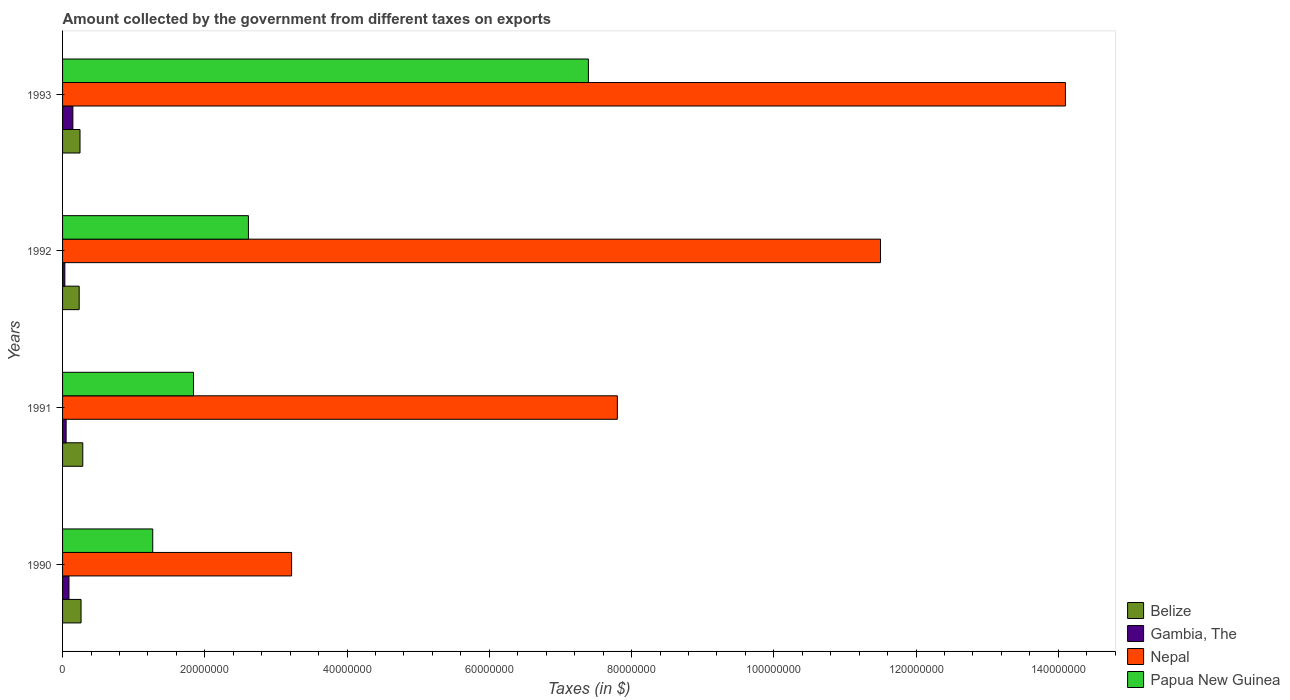What is the label of the 4th group of bars from the top?
Keep it short and to the point. 1990. What is the amount collected by the government from taxes on exports in Papua New Guinea in 1991?
Provide a succinct answer. 1.84e+07. Across all years, what is the maximum amount collected by the government from taxes on exports in Belize?
Your answer should be compact. 2.84e+06. Across all years, what is the minimum amount collected by the government from taxes on exports in Nepal?
Ensure brevity in your answer.  3.22e+07. In which year was the amount collected by the government from taxes on exports in Gambia, The maximum?
Your answer should be compact. 1993. In which year was the amount collected by the government from taxes on exports in Gambia, The minimum?
Your answer should be very brief. 1992. What is the total amount collected by the government from taxes on exports in Nepal in the graph?
Offer a very short reply. 3.66e+08. What is the difference between the amount collected by the government from taxes on exports in Belize in 1990 and that in 1991?
Your response must be concise. -2.42e+05. What is the difference between the amount collected by the government from taxes on exports in Papua New Guinea in 1992 and the amount collected by the government from taxes on exports in Nepal in 1991?
Offer a very short reply. -5.19e+07. What is the average amount collected by the government from taxes on exports in Nepal per year?
Your answer should be very brief. 9.16e+07. In the year 1993, what is the difference between the amount collected by the government from taxes on exports in Belize and amount collected by the government from taxes on exports in Gambia, The?
Provide a short and direct response. 1.00e+06. What is the ratio of the amount collected by the government from taxes on exports in Nepal in 1991 to that in 1992?
Offer a terse response. 0.68. What is the difference between the highest and the second highest amount collected by the government from taxes on exports in Belize?
Provide a short and direct response. 2.42e+05. What is the difference between the highest and the lowest amount collected by the government from taxes on exports in Papua New Guinea?
Offer a very short reply. 6.12e+07. What does the 2nd bar from the top in 1993 represents?
Give a very brief answer. Nepal. What does the 4th bar from the bottom in 1990 represents?
Keep it short and to the point. Papua New Guinea. How many bars are there?
Your answer should be compact. 16. How many years are there in the graph?
Offer a terse response. 4. Does the graph contain any zero values?
Keep it short and to the point. No. Where does the legend appear in the graph?
Give a very brief answer. Bottom right. How are the legend labels stacked?
Give a very brief answer. Vertical. What is the title of the graph?
Your answer should be very brief. Amount collected by the government from different taxes on exports. What is the label or title of the X-axis?
Provide a succinct answer. Taxes (in $). What is the Taxes (in $) in Belize in 1990?
Ensure brevity in your answer.  2.60e+06. What is the Taxes (in $) in Gambia, The in 1990?
Your answer should be compact. 9.00e+05. What is the Taxes (in $) in Nepal in 1990?
Provide a short and direct response. 3.22e+07. What is the Taxes (in $) of Papua New Guinea in 1990?
Your answer should be compact. 1.27e+07. What is the Taxes (in $) of Belize in 1991?
Your answer should be very brief. 2.84e+06. What is the Taxes (in $) of Nepal in 1991?
Your answer should be very brief. 7.80e+07. What is the Taxes (in $) of Papua New Guinea in 1991?
Provide a succinct answer. 1.84e+07. What is the Taxes (in $) of Belize in 1992?
Provide a succinct answer. 2.34e+06. What is the Taxes (in $) of Gambia, The in 1992?
Keep it short and to the point. 3.20e+05. What is the Taxes (in $) of Nepal in 1992?
Your answer should be very brief. 1.15e+08. What is the Taxes (in $) of Papua New Guinea in 1992?
Your answer should be very brief. 2.61e+07. What is the Taxes (in $) of Belize in 1993?
Ensure brevity in your answer.  2.45e+06. What is the Taxes (in $) of Gambia, The in 1993?
Ensure brevity in your answer.  1.45e+06. What is the Taxes (in $) of Nepal in 1993?
Provide a succinct answer. 1.41e+08. What is the Taxes (in $) in Papua New Guinea in 1993?
Offer a terse response. 7.39e+07. Across all years, what is the maximum Taxes (in $) in Belize?
Ensure brevity in your answer.  2.84e+06. Across all years, what is the maximum Taxes (in $) in Gambia, The?
Provide a short and direct response. 1.45e+06. Across all years, what is the maximum Taxes (in $) of Nepal?
Offer a terse response. 1.41e+08. Across all years, what is the maximum Taxes (in $) in Papua New Guinea?
Your answer should be very brief. 7.39e+07. Across all years, what is the minimum Taxes (in $) in Belize?
Offer a very short reply. 2.34e+06. Across all years, what is the minimum Taxes (in $) of Gambia, The?
Keep it short and to the point. 3.20e+05. Across all years, what is the minimum Taxes (in $) in Nepal?
Keep it short and to the point. 3.22e+07. Across all years, what is the minimum Taxes (in $) in Papua New Guinea?
Give a very brief answer. 1.27e+07. What is the total Taxes (in $) in Belize in the graph?
Ensure brevity in your answer.  1.02e+07. What is the total Taxes (in $) in Gambia, The in the graph?
Provide a short and direct response. 3.17e+06. What is the total Taxes (in $) of Nepal in the graph?
Keep it short and to the point. 3.66e+08. What is the total Taxes (in $) of Papua New Guinea in the graph?
Ensure brevity in your answer.  1.31e+08. What is the difference between the Taxes (in $) in Belize in 1990 and that in 1991?
Give a very brief answer. -2.42e+05. What is the difference between the Taxes (in $) of Gambia, The in 1990 and that in 1991?
Your answer should be very brief. 4.00e+05. What is the difference between the Taxes (in $) in Nepal in 1990 and that in 1991?
Ensure brevity in your answer.  -4.58e+07. What is the difference between the Taxes (in $) of Papua New Guinea in 1990 and that in 1991?
Ensure brevity in your answer.  -5.73e+06. What is the difference between the Taxes (in $) in Belize in 1990 and that in 1992?
Provide a short and direct response. 2.65e+05. What is the difference between the Taxes (in $) in Gambia, The in 1990 and that in 1992?
Ensure brevity in your answer.  5.80e+05. What is the difference between the Taxes (in $) in Nepal in 1990 and that in 1992?
Provide a short and direct response. -8.28e+07. What is the difference between the Taxes (in $) in Papua New Guinea in 1990 and that in 1992?
Offer a terse response. -1.34e+07. What is the difference between the Taxes (in $) of Belize in 1990 and that in 1993?
Provide a succinct answer. 1.48e+05. What is the difference between the Taxes (in $) in Gambia, The in 1990 and that in 1993?
Offer a terse response. -5.50e+05. What is the difference between the Taxes (in $) in Nepal in 1990 and that in 1993?
Make the answer very short. -1.09e+08. What is the difference between the Taxes (in $) in Papua New Guinea in 1990 and that in 1993?
Make the answer very short. -6.12e+07. What is the difference between the Taxes (in $) of Belize in 1991 and that in 1992?
Your answer should be compact. 5.07e+05. What is the difference between the Taxes (in $) in Nepal in 1991 and that in 1992?
Your response must be concise. -3.70e+07. What is the difference between the Taxes (in $) of Papua New Guinea in 1991 and that in 1992?
Offer a very short reply. -7.72e+06. What is the difference between the Taxes (in $) of Gambia, The in 1991 and that in 1993?
Offer a terse response. -9.50e+05. What is the difference between the Taxes (in $) of Nepal in 1991 and that in 1993?
Keep it short and to the point. -6.30e+07. What is the difference between the Taxes (in $) in Papua New Guinea in 1991 and that in 1993?
Provide a short and direct response. -5.55e+07. What is the difference between the Taxes (in $) of Belize in 1992 and that in 1993?
Ensure brevity in your answer.  -1.17e+05. What is the difference between the Taxes (in $) in Gambia, The in 1992 and that in 1993?
Your answer should be very brief. -1.13e+06. What is the difference between the Taxes (in $) of Nepal in 1992 and that in 1993?
Keep it short and to the point. -2.60e+07. What is the difference between the Taxes (in $) of Papua New Guinea in 1992 and that in 1993?
Offer a terse response. -4.78e+07. What is the difference between the Taxes (in $) in Belize in 1990 and the Taxes (in $) in Gambia, The in 1991?
Provide a short and direct response. 2.10e+06. What is the difference between the Taxes (in $) of Belize in 1990 and the Taxes (in $) of Nepal in 1991?
Keep it short and to the point. -7.54e+07. What is the difference between the Taxes (in $) in Belize in 1990 and the Taxes (in $) in Papua New Guinea in 1991?
Provide a succinct answer. -1.58e+07. What is the difference between the Taxes (in $) in Gambia, The in 1990 and the Taxes (in $) in Nepal in 1991?
Keep it short and to the point. -7.71e+07. What is the difference between the Taxes (in $) of Gambia, The in 1990 and the Taxes (in $) of Papua New Guinea in 1991?
Provide a short and direct response. -1.75e+07. What is the difference between the Taxes (in $) of Nepal in 1990 and the Taxes (in $) of Papua New Guinea in 1991?
Ensure brevity in your answer.  1.38e+07. What is the difference between the Taxes (in $) of Belize in 1990 and the Taxes (in $) of Gambia, The in 1992?
Provide a succinct answer. 2.28e+06. What is the difference between the Taxes (in $) of Belize in 1990 and the Taxes (in $) of Nepal in 1992?
Ensure brevity in your answer.  -1.12e+08. What is the difference between the Taxes (in $) in Belize in 1990 and the Taxes (in $) in Papua New Guinea in 1992?
Offer a terse response. -2.35e+07. What is the difference between the Taxes (in $) in Gambia, The in 1990 and the Taxes (in $) in Nepal in 1992?
Keep it short and to the point. -1.14e+08. What is the difference between the Taxes (in $) in Gambia, The in 1990 and the Taxes (in $) in Papua New Guinea in 1992?
Offer a terse response. -2.52e+07. What is the difference between the Taxes (in $) of Nepal in 1990 and the Taxes (in $) of Papua New Guinea in 1992?
Give a very brief answer. 6.07e+06. What is the difference between the Taxes (in $) of Belize in 1990 and the Taxes (in $) of Gambia, The in 1993?
Your answer should be compact. 1.15e+06. What is the difference between the Taxes (in $) in Belize in 1990 and the Taxes (in $) in Nepal in 1993?
Keep it short and to the point. -1.38e+08. What is the difference between the Taxes (in $) of Belize in 1990 and the Taxes (in $) of Papua New Guinea in 1993?
Provide a short and direct response. -7.13e+07. What is the difference between the Taxes (in $) in Gambia, The in 1990 and the Taxes (in $) in Nepal in 1993?
Give a very brief answer. -1.40e+08. What is the difference between the Taxes (in $) in Gambia, The in 1990 and the Taxes (in $) in Papua New Guinea in 1993?
Offer a terse response. -7.30e+07. What is the difference between the Taxes (in $) in Nepal in 1990 and the Taxes (in $) in Papua New Guinea in 1993?
Ensure brevity in your answer.  -4.17e+07. What is the difference between the Taxes (in $) in Belize in 1991 and the Taxes (in $) in Gambia, The in 1992?
Make the answer very short. 2.52e+06. What is the difference between the Taxes (in $) in Belize in 1991 and the Taxes (in $) in Nepal in 1992?
Give a very brief answer. -1.12e+08. What is the difference between the Taxes (in $) in Belize in 1991 and the Taxes (in $) in Papua New Guinea in 1992?
Give a very brief answer. -2.33e+07. What is the difference between the Taxes (in $) in Gambia, The in 1991 and the Taxes (in $) in Nepal in 1992?
Your response must be concise. -1.14e+08. What is the difference between the Taxes (in $) of Gambia, The in 1991 and the Taxes (in $) of Papua New Guinea in 1992?
Your answer should be compact. -2.56e+07. What is the difference between the Taxes (in $) in Nepal in 1991 and the Taxes (in $) in Papua New Guinea in 1992?
Offer a very short reply. 5.19e+07. What is the difference between the Taxes (in $) of Belize in 1991 and the Taxes (in $) of Gambia, The in 1993?
Offer a very short reply. 1.39e+06. What is the difference between the Taxes (in $) of Belize in 1991 and the Taxes (in $) of Nepal in 1993?
Your answer should be compact. -1.38e+08. What is the difference between the Taxes (in $) in Belize in 1991 and the Taxes (in $) in Papua New Guinea in 1993?
Give a very brief answer. -7.11e+07. What is the difference between the Taxes (in $) in Gambia, The in 1991 and the Taxes (in $) in Nepal in 1993?
Ensure brevity in your answer.  -1.40e+08. What is the difference between the Taxes (in $) of Gambia, The in 1991 and the Taxes (in $) of Papua New Guinea in 1993?
Give a very brief answer. -7.34e+07. What is the difference between the Taxes (in $) of Nepal in 1991 and the Taxes (in $) of Papua New Guinea in 1993?
Provide a short and direct response. 4.07e+06. What is the difference between the Taxes (in $) of Belize in 1992 and the Taxes (in $) of Gambia, The in 1993?
Give a very brief answer. 8.86e+05. What is the difference between the Taxes (in $) of Belize in 1992 and the Taxes (in $) of Nepal in 1993?
Ensure brevity in your answer.  -1.39e+08. What is the difference between the Taxes (in $) of Belize in 1992 and the Taxes (in $) of Papua New Guinea in 1993?
Make the answer very short. -7.16e+07. What is the difference between the Taxes (in $) of Gambia, The in 1992 and the Taxes (in $) of Nepal in 1993?
Your response must be concise. -1.41e+08. What is the difference between the Taxes (in $) of Gambia, The in 1992 and the Taxes (in $) of Papua New Guinea in 1993?
Your response must be concise. -7.36e+07. What is the difference between the Taxes (in $) in Nepal in 1992 and the Taxes (in $) in Papua New Guinea in 1993?
Keep it short and to the point. 4.11e+07. What is the average Taxes (in $) of Belize per year?
Provide a short and direct response. 2.56e+06. What is the average Taxes (in $) of Gambia, The per year?
Your answer should be compact. 7.92e+05. What is the average Taxes (in $) of Nepal per year?
Your response must be concise. 9.16e+07. What is the average Taxes (in $) in Papua New Guinea per year?
Provide a short and direct response. 3.28e+07. In the year 1990, what is the difference between the Taxes (in $) of Belize and Taxes (in $) of Gambia, The?
Your answer should be compact. 1.70e+06. In the year 1990, what is the difference between the Taxes (in $) in Belize and Taxes (in $) in Nepal?
Make the answer very short. -2.96e+07. In the year 1990, what is the difference between the Taxes (in $) in Belize and Taxes (in $) in Papua New Guinea?
Keep it short and to the point. -1.01e+07. In the year 1990, what is the difference between the Taxes (in $) of Gambia, The and Taxes (in $) of Nepal?
Offer a terse response. -3.13e+07. In the year 1990, what is the difference between the Taxes (in $) of Gambia, The and Taxes (in $) of Papua New Guinea?
Your response must be concise. -1.18e+07. In the year 1990, what is the difference between the Taxes (in $) in Nepal and Taxes (in $) in Papua New Guinea?
Make the answer very short. 1.95e+07. In the year 1991, what is the difference between the Taxes (in $) of Belize and Taxes (in $) of Gambia, The?
Your response must be concise. 2.34e+06. In the year 1991, what is the difference between the Taxes (in $) in Belize and Taxes (in $) in Nepal?
Give a very brief answer. -7.52e+07. In the year 1991, what is the difference between the Taxes (in $) of Belize and Taxes (in $) of Papua New Guinea?
Provide a short and direct response. -1.56e+07. In the year 1991, what is the difference between the Taxes (in $) of Gambia, The and Taxes (in $) of Nepal?
Ensure brevity in your answer.  -7.75e+07. In the year 1991, what is the difference between the Taxes (in $) of Gambia, The and Taxes (in $) of Papua New Guinea?
Provide a short and direct response. -1.79e+07. In the year 1991, what is the difference between the Taxes (in $) in Nepal and Taxes (in $) in Papua New Guinea?
Give a very brief answer. 5.96e+07. In the year 1992, what is the difference between the Taxes (in $) of Belize and Taxes (in $) of Gambia, The?
Offer a very short reply. 2.02e+06. In the year 1992, what is the difference between the Taxes (in $) of Belize and Taxes (in $) of Nepal?
Provide a succinct answer. -1.13e+08. In the year 1992, what is the difference between the Taxes (in $) in Belize and Taxes (in $) in Papua New Guinea?
Keep it short and to the point. -2.38e+07. In the year 1992, what is the difference between the Taxes (in $) of Gambia, The and Taxes (in $) of Nepal?
Make the answer very short. -1.15e+08. In the year 1992, what is the difference between the Taxes (in $) of Gambia, The and Taxes (in $) of Papua New Guinea?
Provide a succinct answer. -2.58e+07. In the year 1992, what is the difference between the Taxes (in $) of Nepal and Taxes (in $) of Papua New Guinea?
Your response must be concise. 8.89e+07. In the year 1993, what is the difference between the Taxes (in $) in Belize and Taxes (in $) in Gambia, The?
Make the answer very short. 1.00e+06. In the year 1993, what is the difference between the Taxes (in $) in Belize and Taxes (in $) in Nepal?
Provide a short and direct response. -1.39e+08. In the year 1993, what is the difference between the Taxes (in $) in Belize and Taxes (in $) in Papua New Guinea?
Your answer should be very brief. -7.15e+07. In the year 1993, what is the difference between the Taxes (in $) in Gambia, The and Taxes (in $) in Nepal?
Your response must be concise. -1.40e+08. In the year 1993, what is the difference between the Taxes (in $) in Gambia, The and Taxes (in $) in Papua New Guinea?
Give a very brief answer. -7.25e+07. In the year 1993, what is the difference between the Taxes (in $) in Nepal and Taxes (in $) in Papua New Guinea?
Keep it short and to the point. 6.71e+07. What is the ratio of the Taxes (in $) of Belize in 1990 to that in 1991?
Your answer should be compact. 0.91. What is the ratio of the Taxes (in $) of Nepal in 1990 to that in 1991?
Offer a terse response. 0.41. What is the ratio of the Taxes (in $) in Papua New Guinea in 1990 to that in 1991?
Your answer should be compact. 0.69. What is the ratio of the Taxes (in $) of Belize in 1990 to that in 1992?
Make the answer very short. 1.11. What is the ratio of the Taxes (in $) in Gambia, The in 1990 to that in 1992?
Make the answer very short. 2.81. What is the ratio of the Taxes (in $) of Nepal in 1990 to that in 1992?
Keep it short and to the point. 0.28. What is the ratio of the Taxes (in $) in Papua New Guinea in 1990 to that in 1992?
Provide a short and direct response. 0.49. What is the ratio of the Taxes (in $) of Belize in 1990 to that in 1993?
Provide a succinct answer. 1.06. What is the ratio of the Taxes (in $) in Gambia, The in 1990 to that in 1993?
Your response must be concise. 0.62. What is the ratio of the Taxes (in $) of Nepal in 1990 to that in 1993?
Offer a very short reply. 0.23. What is the ratio of the Taxes (in $) of Papua New Guinea in 1990 to that in 1993?
Offer a terse response. 0.17. What is the ratio of the Taxes (in $) in Belize in 1991 to that in 1992?
Your response must be concise. 1.22. What is the ratio of the Taxes (in $) of Gambia, The in 1991 to that in 1992?
Provide a short and direct response. 1.56. What is the ratio of the Taxes (in $) of Nepal in 1991 to that in 1992?
Ensure brevity in your answer.  0.68. What is the ratio of the Taxes (in $) of Papua New Guinea in 1991 to that in 1992?
Offer a very short reply. 0.7. What is the ratio of the Taxes (in $) of Belize in 1991 to that in 1993?
Offer a terse response. 1.16. What is the ratio of the Taxes (in $) in Gambia, The in 1991 to that in 1993?
Provide a short and direct response. 0.34. What is the ratio of the Taxes (in $) of Nepal in 1991 to that in 1993?
Keep it short and to the point. 0.55. What is the ratio of the Taxes (in $) in Papua New Guinea in 1991 to that in 1993?
Keep it short and to the point. 0.25. What is the ratio of the Taxes (in $) of Belize in 1992 to that in 1993?
Give a very brief answer. 0.95. What is the ratio of the Taxes (in $) in Gambia, The in 1992 to that in 1993?
Your answer should be very brief. 0.22. What is the ratio of the Taxes (in $) in Nepal in 1992 to that in 1993?
Provide a short and direct response. 0.82. What is the ratio of the Taxes (in $) in Papua New Guinea in 1992 to that in 1993?
Your answer should be compact. 0.35. What is the difference between the highest and the second highest Taxes (in $) in Belize?
Keep it short and to the point. 2.42e+05. What is the difference between the highest and the second highest Taxes (in $) in Gambia, The?
Your response must be concise. 5.50e+05. What is the difference between the highest and the second highest Taxes (in $) in Nepal?
Make the answer very short. 2.60e+07. What is the difference between the highest and the second highest Taxes (in $) of Papua New Guinea?
Make the answer very short. 4.78e+07. What is the difference between the highest and the lowest Taxes (in $) of Belize?
Your response must be concise. 5.07e+05. What is the difference between the highest and the lowest Taxes (in $) in Gambia, The?
Provide a succinct answer. 1.13e+06. What is the difference between the highest and the lowest Taxes (in $) in Nepal?
Make the answer very short. 1.09e+08. What is the difference between the highest and the lowest Taxes (in $) of Papua New Guinea?
Your response must be concise. 6.12e+07. 